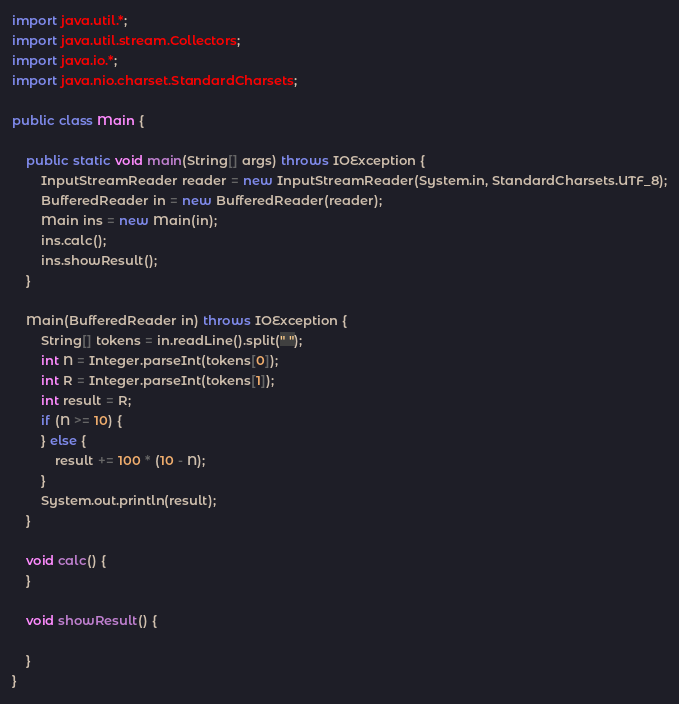<code> <loc_0><loc_0><loc_500><loc_500><_Java_>import java.util.*;
import java.util.stream.Collectors;
import java.io.*;
import java.nio.charset.StandardCharsets;

public class Main {

	public static void main(String[] args) throws IOException {
		InputStreamReader reader = new InputStreamReader(System.in, StandardCharsets.UTF_8);
		BufferedReader in = new BufferedReader(reader);
		Main ins = new Main(in);
		ins.calc();
		ins.showResult();
	}

	Main(BufferedReader in) throws IOException {
		String[] tokens = in.readLine().split(" ");
		int N = Integer.parseInt(tokens[0]);
		int R = Integer.parseInt(tokens[1]);
		int result = R;
		if (N >= 10) {
		} else {
			result += 100 * (10 - N);
		}
		System.out.println(result);
	}

	void calc() {
	}

	void showResult() {

	}
}
</code> 